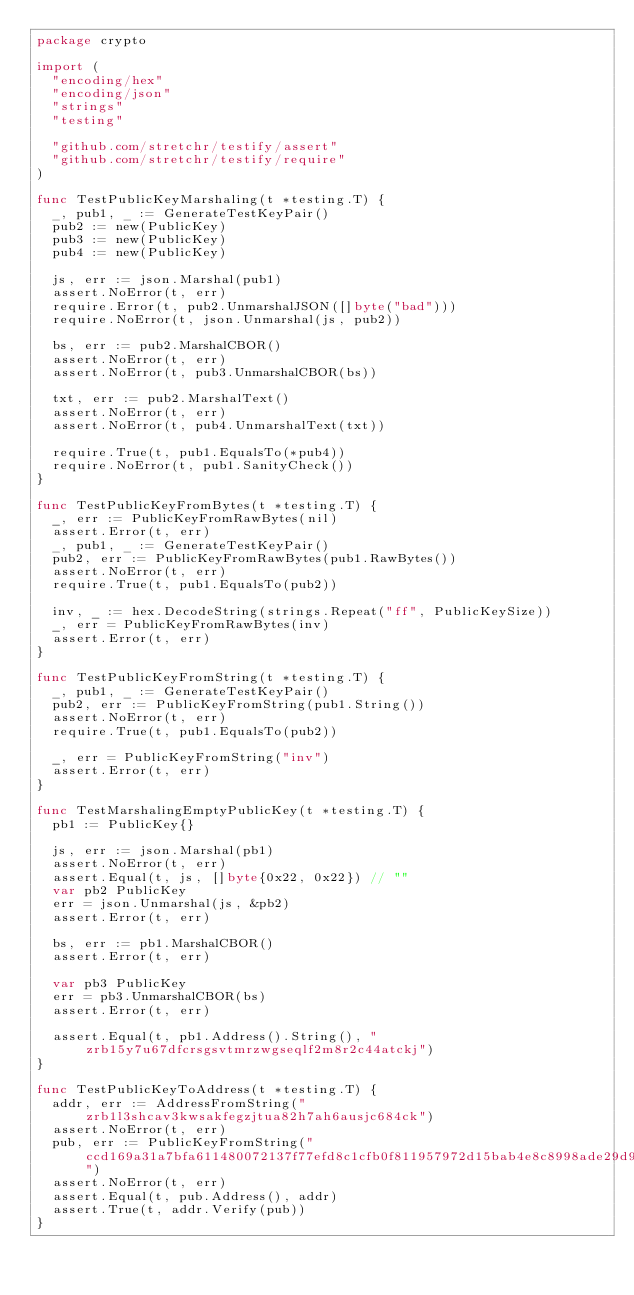Convert code to text. <code><loc_0><loc_0><loc_500><loc_500><_Go_>package crypto

import (
	"encoding/hex"
	"encoding/json"
	"strings"
	"testing"

	"github.com/stretchr/testify/assert"
	"github.com/stretchr/testify/require"
)

func TestPublicKeyMarshaling(t *testing.T) {
	_, pub1, _ := GenerateTestKeyPair()
	pub2 := new(PublicKey)
	pub3 := new(PublicKey)
	pub4 := new(PublicKey)

	js, err := json.Marshal(pub1)
	assert.NoError(t, err)
	require.Error(t, pub2.UnmarshalJSON([]byte("bad")))
	require.NoError(t, json.Unmarshal(js, pub2))

	bs, err := pub2.MarshalCBOR()
	assert.NoError(t, err)
	assert.NoError(t, pub3.UnmarshalCBOR(bs))

	txt, err := pub2.MarshalText()
	assert.NoError(t, err)
	assert.NoError(t, pub4.UnmarshalText(txt))

	require.True(t, pub1.EqualsTo(*pub4))
	require.NoError(t, pub1.SanityCheck())
}

func TestPublicKeyFromBytes(t *testing.T) {
	_, err := PublicKeyFromRawBytes(nil)
	assert.Error(t, err)
	_, pub1, _ := GenerateTestKeyPair()
	pub2, err := PublicKeyFromRawBytes(pub1.RawBytes())
	assert.NoError(t, err)
	require.True(t, pub1.EqualsTo(pub2))

	inv, _ := hex.DecodeString(strings.Repeat("ff", PublicKeySize))
	_, err = PublicKeyFromRawBytes(inv)
	assert.Error(t, err)
}

func TestPublicKeyFromString(t *testing.T) {
	_, pub1, _ := GenerateTestKeyPair()
	pub2, err := PublicKeyFromString(pub1.String())
	assert.NoError(t, err)
	require.True(t, pub1.EqualsTo(pub2))

	_, err = PublicKeyFromString("inv")
	assert.Error(t, err)
}

func TestMarshalingEmptyPublicKey(t *testing.T) {
	pb1 := PublicKey{}

	js, err := json.Marshal(pb1)
	assert.NoError(t, err)
	assert.Equal(t, js, []byte{0x22, 0x22}) // ""
	var pb2 PublicKey
	err = json.Unmarshal(js, &pb2)
	assert.Error(t, err)

	bs, err := pb1.MarshalCBOR()
	assert.Error(t, err)

	var pb3 PublicKey
	err = pb3.UnmarshalCBOR(bs)
	assert.Error(t, err)

	assert.Equal(t, pb1.Address().String(), "zrb15y7u67dfcrsgsvtmrzwgseqlf2m8r2c44atckj")
}

func TestPublicKeyToAddress(t *testing.T) {
	addr, err := AddressFromString("zrb1l3shcav3kwsakfegzjtua82h7ah6ausjc684ck")
	assert.NoError(t, err)
	pub, err := PublicKeyFromString("ccd169a31a7bfa611480072137f77efd8c1cfb0f811957972d15bab4e8c8998ade29d99b03815d3873e57d21e67ce210480270ca0b77698de0623ab1e6a241bd05a00a2e3a5b319c99fa1b9ecb6f53564e4c53dbb8a2b6b46315bf258208f614")
	assert.NoError(t, err)
	assert.Equal(t, pub.Address(), addr)
	assert.True(t, addr.Verify(pub))
}
</code> 